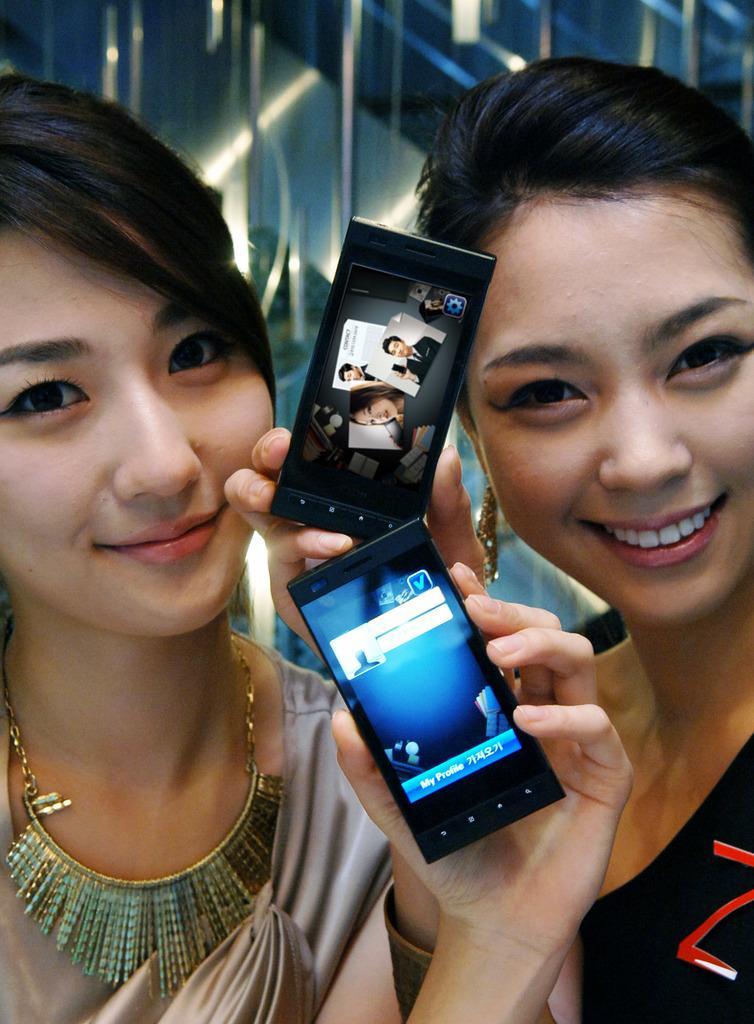Could you give a brief overview of what you see in this image? This picture seems to be of inside. In the foreground there are two women smiling, holding a mobile phone and seems to be standing. In the background we can see the lights. 